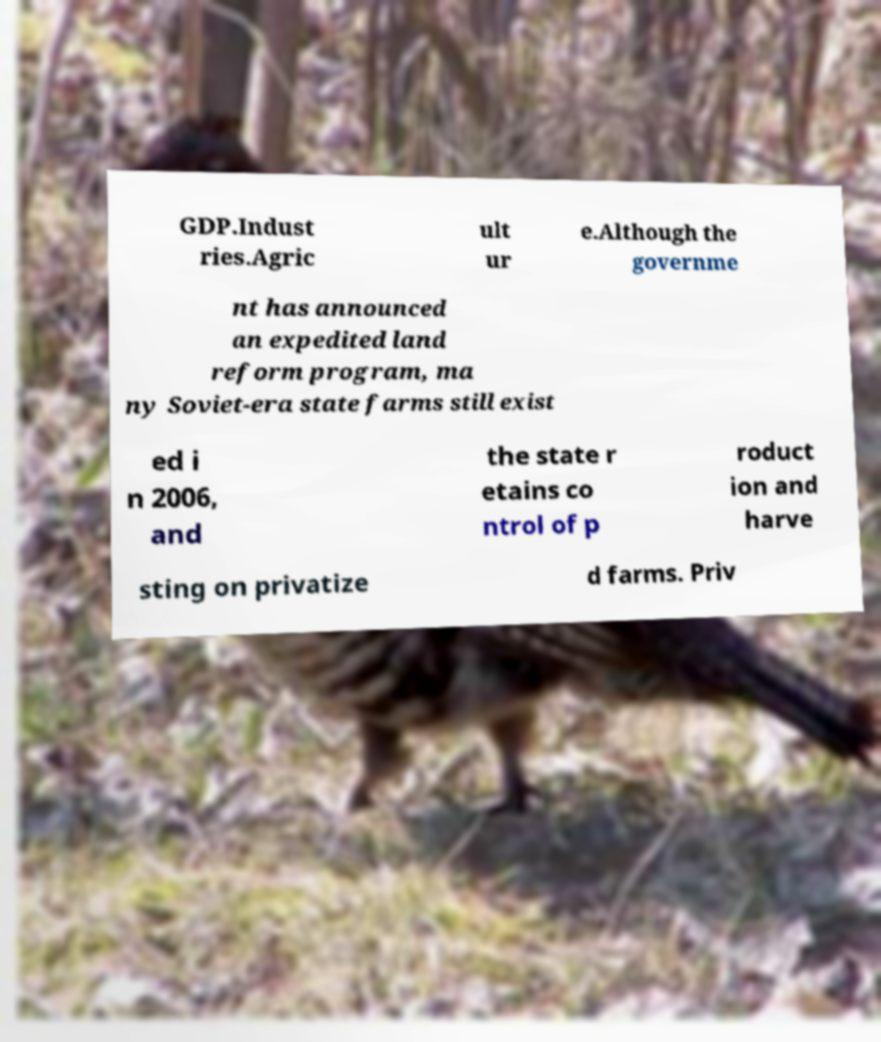What messages or text are displayed in this image? I need them in a readable, typed format. GDP.Indust ries.Agric ult ur e.Although the governme nt has announced an expedited land reform program, ma ny Soviet-era state farms still exist ed i n 2006, and the state r etains co ntrol of p roduct ion and harve sting on privatize d farms. Priv 